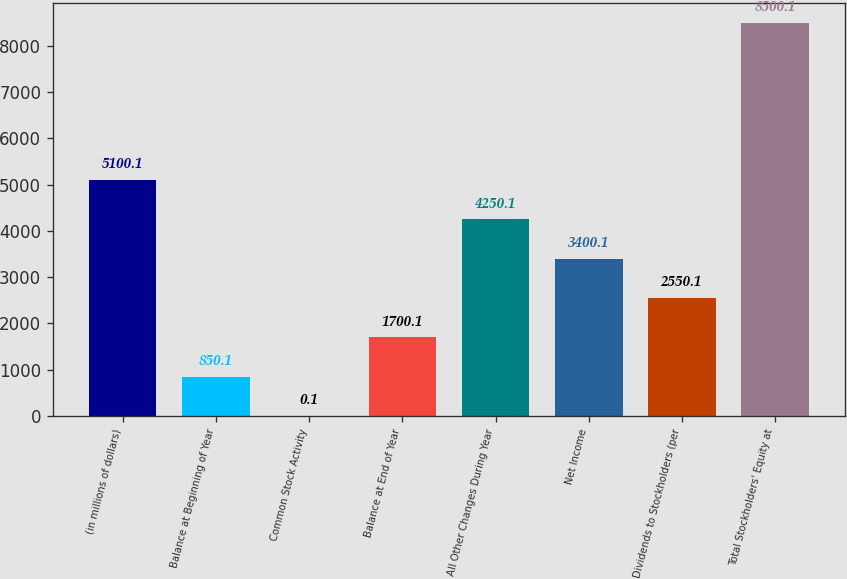Convert chart to OTSL. <chart><loc_0><loc_0><loc_500><loc_500><bar_chart><fcel>(in millions of dollars)<fcel>Balance at Beginning of Year<fcel>Common Stock Activity<fcel>Balance at End of Year<fcel>All Other Changes During Year<fcel>Net Income<fcel>Dividends to Stockholders (per<fcel>Total Stockholders' Equity at<nl><fcel>5100.1<fcel>850.1<fcel>0.1<fcel>1700.1<fcel>4250.1<fcel>3400.1<fcel>2550.1<fcel>8500.1<nl></chart> 